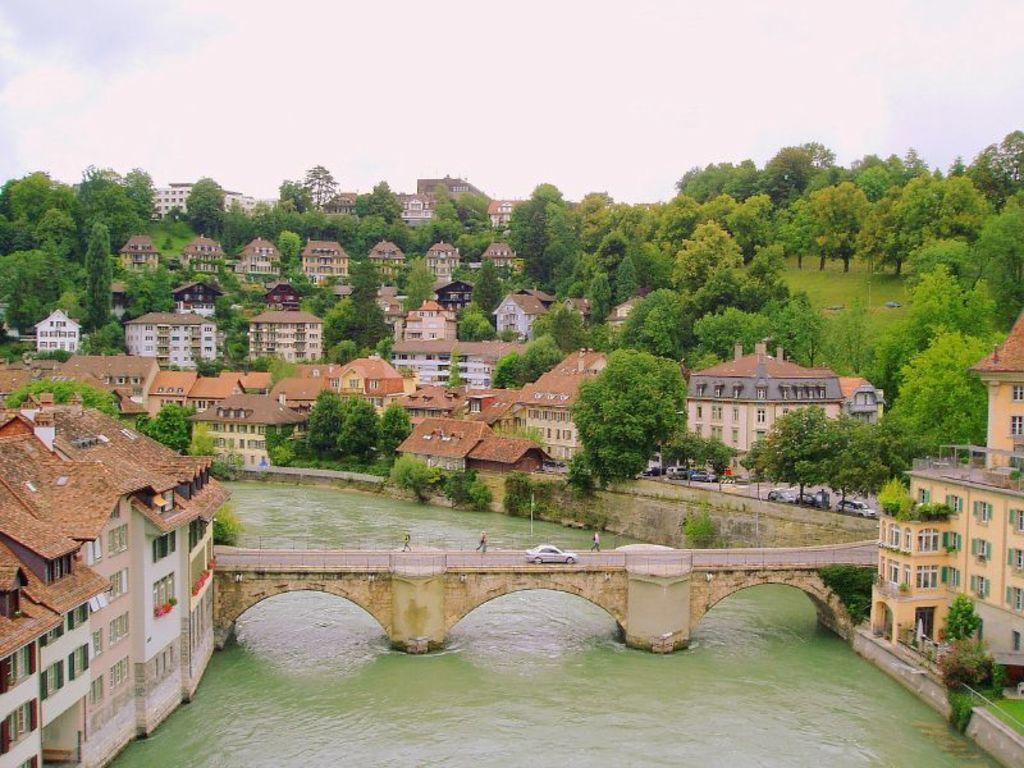What structures can be seen in the image? There are buildings in the image. What is located in the center of the image? There is a bridge in the center of the image. What is happening on the bridge? There are persons on the bridge, and there is a car on the bridge. What can be seen in the background of the image? There are trees and a cloudy sky in the background of the image. What type of cattle can be seen grazing on the bridge in the image? There are no cattle present in the image; the bridge has persons and a car on it. What decisions is the committee making in the image? There is no committee present in the image; the focus is on the bridge, buildings, and background elements. 